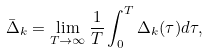<formula> <loc_0><loc_0><loc_500><loc_500>\bar { \Delta } _ { k } = \lim _ { T \rightarrow \infty } \frac { 1 } { T } \int _ { 0 } ^ { T } \Delta _ { k } ( \tau ) d \tau ,</formula> 